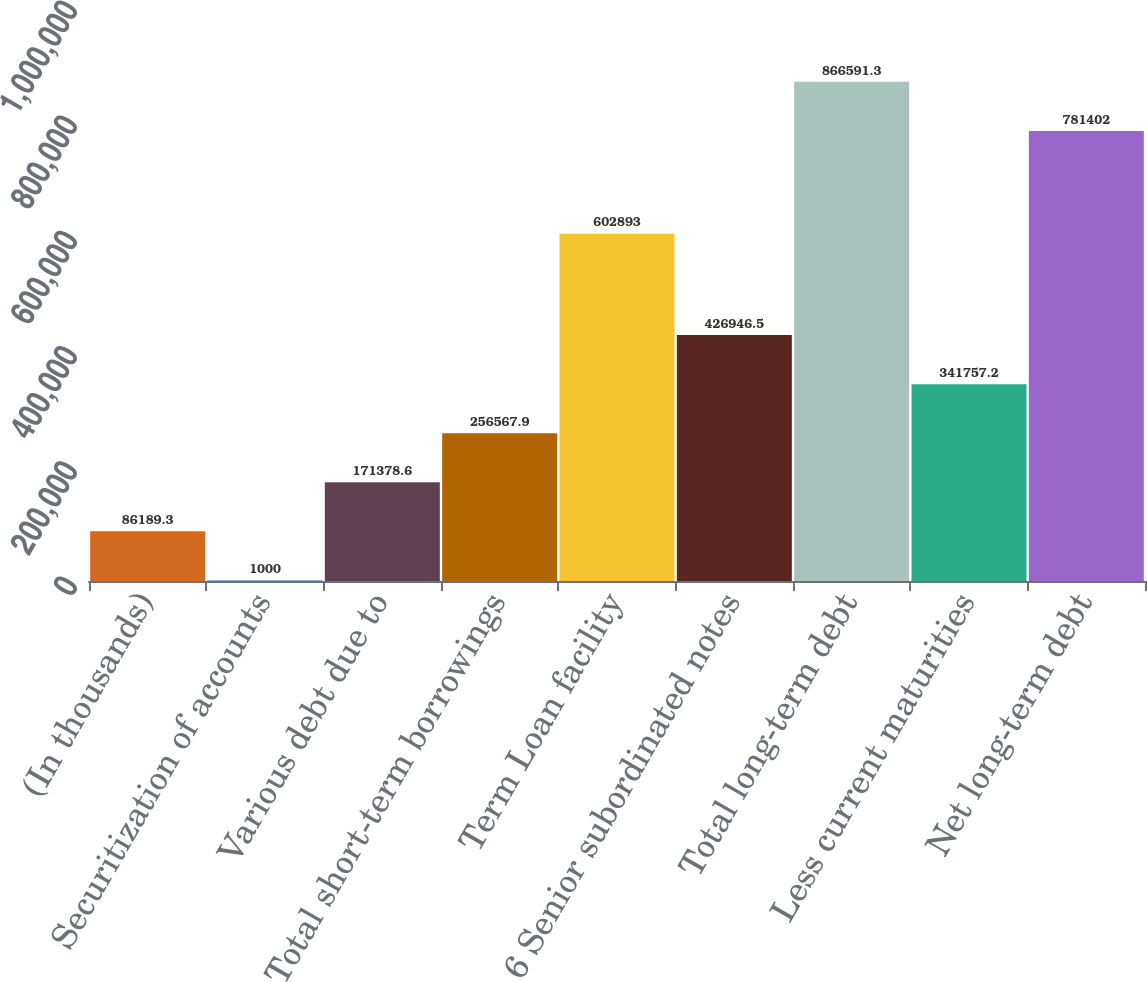Convert chart to OTSL. <chart><loc_0><loc_0><loc_500><loc_500><bar_chart><fcel>(In thousands)<fcel>Securitization of accounts<fcel>Various debt due to<fcel>Total short-term borrowings<fcel>Term Loan facility<fcel>6 Senior subordinated notes<fcel>Total long-term debt<fcel>Less current maturities<fcel>Net long-term debt<nl><fcel>86189.3<fcel>1000<fcel>171379<fcel>256568<fcel>602893<fcel>426946<fcel>866591<fcel>341757<fcel>781402<nl></chart> 